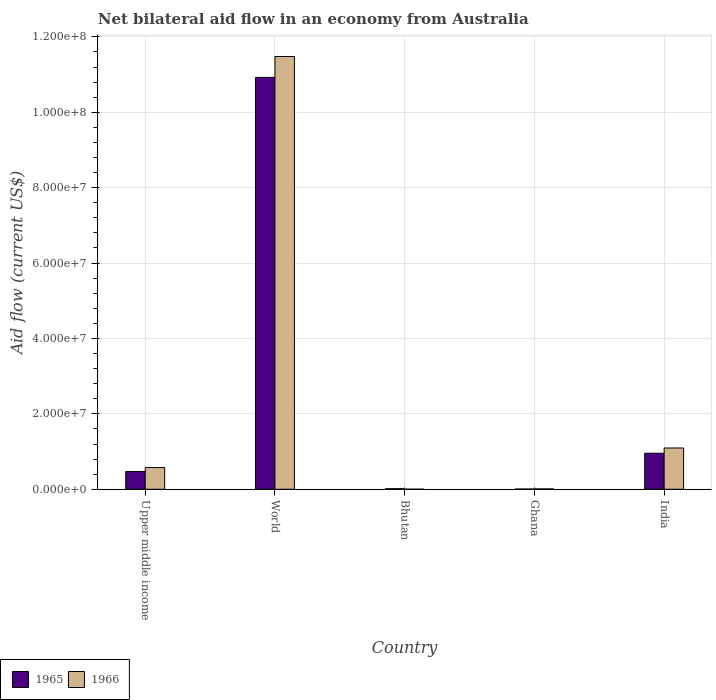How many groups of bars are there?
Offer a very short reply. 5. Are the number of bars per tick equal to the number of legend labels?
Your answer should be compact. Yes. How many bars are there on the 2nd tick from the left?
Your answer should be compact. 2. How many bars are there on the 3rd tick from the right?
Offer a terse response. 2. In how many cases, is the number of bars for a given country not equal to the number of legend labels?
Keep it short and to the point. 0. What is the net bilateral aid flow in 1966 in India?
Make the answer very short. 1.10e+07. Across all countries, what is the maximum net bilateral aid flow in 1966?
Offer a very short reply. 1.15e+08. In which country was the net bilateral aid flow in 1965 minimum?
Provide a short and direct response. Ghana. What is the total net bilateral aid flow in 1966 in the graph?
Ensure brevity in your answer.  1.32e+08. What is the difference between the net bilateral aid flow in 1966 in Ghana and that in India?
Your answer should be compact. -1.08e+07. What is the difference between the net bilateral aid flow in 1965 in Upper middle income and the net bilateral aid flow in 1966 in India?
Provide a short and direct response. -6.22e+06. What is the average net bilateral aid flow in 1965 per country?
Provide a succinct answer. 2.48e+07. In how many countries, is the net bilateral aid flow in 1965 greater than 108000000 US$?
Your answer should be compact. 1. What is the ratio of the net bilateral aid flow in 1966 in Ghana to that in India?
Make the answer very short. 0.01. Is the difference between the net bilateral aid flow in 1966 in India and World greater than the difference between the net bilateral aid flow in 1965 in India and World?
Provide a succinct answer. No. What is the difference between the highest and the second highest net bilateral aid flow in 1965?
Provide a short and direct response. 1.05e+08. What is the difference between the highest and the lowest net bilateral aid flow in 1966?
Give a very brief answer. 1.15e+08. What does the 2nd bar from the left in India represents?
Provide a succinct answer. 1966. What does the 1st bar from the right in Ghana represents?
Your answer should be compact. 1966. Where does the legend appear in the graph?
Your answer should be compact. Bottom left. How many legend labels are there?
Ensure brevity in your answer.  2. How are the legend labels stacked?
Provide a succinct answer. Horizontal. What is the title of the graph?
Your answer should be very brief. Net bilateral aid flow in an economy from Australia. Does "1969" appear as one of the legend labels in the graph?
Provide a succinct answer. No. What is the Aid flow (current US$) of 1965 in Upper middle income?
Your answer should be very brief. 4.73e+06. What is the Aid flow (current US$) in 1966 in Upper middle income?
Your answer should be very brief. 5.76e+06. What is the Aid flow (current US$) in 1965 in World?
Offer a terse response. 1.09e+08. What is the Aid flow (current US$) in 1966 in World?
Keep it short and to the point. 1.15e+08. What is the Aid flow (current US$) in 1966 in Ghana?
Give a very brief answer. 1.10e+05. What is the Aid flow (current US$) in 1965 in India?
Make the answer very short. 9.56e+06. What is the Aid flow (current US$) in 1966 in India?
Your answer should be very brief. 1.10e+07. Across all countries, what is the maximum Aid flow (current US$) in 1965?
Ensure brevity in your answer.  1.09e+08. Across all countries, what is the maximum Aid flow (current US$) in 1966?
Ensure brevity in your answer.  1.15e+08. What is the total Aid flow (current US$) of 1965 in the graph?
Your answer should be very brief. 1.24e+08. What is the total Aid flow (current US$) of 1966 in the graph?
Your response must be concise. 1.32e+08. What is the difference between the Aid flow (current US$) in 1965 in Upper middle income and that in World?
Your response must be concise. -1.05e+08. What is the difference between the Aid flow (current US$) of 1966 in Upper middle income and that in World?
Ensure brevity in your answer.  -1.09e+08. What is the difference between the Aid flow (current US$) of 1965 in Upper middle income and that in Bhutan?
Provide a short and direct response. 4.58e+06. What is the difference between the Aid flow (current US$) of 1966 in Upper middle income and that in Bhutan?
Give a very brief answer. 5.74e+06. What is the difference between the Aid flow (current US$) of 1965 in Upper middle income and that in Ghana?
Offer a terse response. 4.66e+06. What is the difference between the Aid flow (current US$) in 1966 in Upper middle income and that in Ghana?
Keep it short and to the point. 5.65e+06. What is the difference between the Aid flow (current US$) in 1965 in Upper middle income and that in India?
Offer a terse response. -4.83e+06. What is the difference between the Aid flow (current US$) of 1966 in Upper middle income and that in India?
Make the answer very short. -5.19e+06. What is the difference between the Aid flow (current US$) of 1965 in World and that in Bhutan?
Your answer should be very brief. 1.09e+08. What is the difference between the Aid flow (current US$) of 1966 in World and that in Bhutan?
Keep it short and to the point. 1.15e+08. What is the difference between the Aid flow (current US$) of 1965 in World and that in Ghana?
Your answer should be very brief. 1.09e+08. What is the difference between the Aid flow (current US$) in 1966 in World and that in Ghana?
Ensure brevity in your answer.  1.15e+08. What is the difference between the Aid flow (current US$) in 1965 in World and that in India?
Ensure brevity in your answer.  9.97e+07. What is the difference between the Aid flow (current US$) in 1966 in World and that in India?
Provide a short and direct response. 1.04e+08. What is the difference between the Aid flow (current US$) in 1965 in Bhutan and that in Ghana?
Make the answer very short. 8.00e+04. What is the difference between the Aid flow (current US$) in 1965 in Bhutan and that in India?
Offer a very short reply. -9.41e+06. What is the difference between the Aid flow (current US$) of 1966 in Bhutan and that in India?
Offer a terse response. -1.09e+07. What is the difference between the Aid flow (current US$) of 1965 in Ghana and that in India?
Your answer should be compact. -9.49e+06. What is the difference between the Aid flow (current US$) of 1966 in Ghana and that in India?
Provide a short and direct response. -1.08e+07. What is the difference between the Aid flow (current US$) of 1965 in Upper middle income and the Aid flow (current US$) of 1966 in World?
Ensure brevity in your answer.  -1.10e+08. What is the difference between the Aid flow (current US$) of 1965 in Upper middle income and the Aid flow (current US$) of 1966 in Bhutan?
Provide a short and direct response. 4.71e+06. What is the difference between the Aid flow (current US$) in 1965 in Upper middle income and the Aid flow (current US$) in 1966 in Ghana?
Make the answer very short. 4.62e+06. What is the difference between the Aid flow (current US$) in 1965 in Upper middle income and the Aid flow (current US$) in 1966 in India?
Give a very brief answer. -6.22e+06. What is the difference between the Aid flow (current US$) of 1965 in World and the Aid flow (current US$) of 1966 in Bhutan?
Give a very brief answer. 1.09e+08. What is the difference between the Aid flow (current US$) of 1965 in World and the Aid flow (current US$) of 1966 in Ghana?
Your answer should be compact. 1.09e+08. What is the difference between the Aid flow (current US$) in 1965 in World and the Aid flow (current US$) in 1966 in India?
Offer a terse response. 9.83e+07. What is the difference between the Aid flow (current US$) in 1965 in Bhutan and the Aid flow (current US$) in 1966 in India?
Your response must be concise. -1.08e+07. What is the difference between the Aid flow (current US$) of 1965 in Ghana and the Aid flow (current US$) of 1966 in India?
Make the answer very short. -1.09e+07. What is the average Aid flow (current US$) in 1965 per country?
Give a very brief answer. 2.48e+07. What is the average Aid flow (current US$) of 1966 per country?
Offer a very short reply. 2.63e+07. What is the difference between the Aid flow (current US$) of 1965 and Aid flow (current US$) of 1966 in Upper middle income?
Provide a succinct answer. -1.03e+06. What is the difference between the Aid flow (current US$) in 1965 and Aid flow (current US$) in 1966 in World?
Give a very brief answer. -5.54e+06. What is the difference between the Aid flow (current US$) of 1965 and Aid flow (current US$) of 1966 in India?
Give a very brief answer. -1.39e+06. What is the ratio of the Aid flow (current US$) of 1965 in Upper middle income to that in World?
Make the answer very short. 0.04. What is the ratio of the Aid flow (current US$) in 1966 in Upper middle income to that in World?
Offer a terse response. 0.05. What is the ratio of the Aid flow (current US$) in 1965 in Upper middle income to that in Bhutan?
Your answer should be compact. 31.53. What is the ratio of the Aid flow (current US$) in 1966 in Upper middle income to that in Bhutan?
Give a very brief answer. 288. What is the ratio of the Aid flow (current US$) in 1965 in Upper middle income to that in Ghana?
Your answer should be compact. 67.57. What is the ratio of the Aid flow (current US$) in 1966 in Upper middle income to that in Ghana?
Your answer should be compact. 52.36. What is the ratio of the Aid flow (current US$) of 1965 in Upper middle income to that in India?
Provide a short and direct response. 0.49. What is the ratio of the Aid flow (current US$) in 1966 in Upper middle income to that in India?
Your answer should be compact. 0.53. What is the ratio of the Aid flow (current US$) of 1965 in World to that in Bhutan?
Your response must be concise. 728.33. What is the ratio of the Aid flow (current US$) in 1966 in World to that in Bhutan?
Ensure brevity in your answer.  5739.5. What is the ratio of the Aid flow (current US$) in 1965 in World to that in Ghana?
Provide a succinct answer. 1560.71. What is the ratio of the Aid flow (current US$) of 1966 in World to that in Ghana?
Offer a terse response. 1043.55. What is the ratio of the Aid flow (current US$) in 1965 in World to that in India?
Offer a very short reply. 11.43. What is the ratio of the Aid flow (current US$) in 1966 in World to that in India?
Give a very brief answer. 10.48. What is the ratio of the Aid flow (current US$) of 1965 in Bhutan to that in Ghana?
Your response must be concise. 2.14. What is the ratio of the Aid flow (current US$) in 1966 in Bhutan to that in Ghana?
Provide a short and direct response. 0.18. What is the ratio of the Aid flow (current US$) of 1965 in Bhutan to that in India?
Make the answer very short. 0.02. What is the ratio of the Aid flow (current US$) of 1966 in Bhutan to that in India?
Provide a succinct answer. 0. What is the ratio of the Aid flow (current US$) of 1965 in Ghana to that in India?
Keep it short and to the point. 0.01. What is the difference between the highest and the second highest Aid flow (current US$) of 1965?
Your response must be concise. 9.97e+07. What is the difference between the highest and the second highest Aid flow (current US$) of 1966?
Make the answer very short. 1.04e+08. What is the difference between the highest and the lowest Aid flow (current US$) of 1965?
Make the answer very short. 1.09e+08. What is the difference between the highest and the lowest Aid flow (current US$) of 1966?
Offer a terse response. 1.15e+08. 